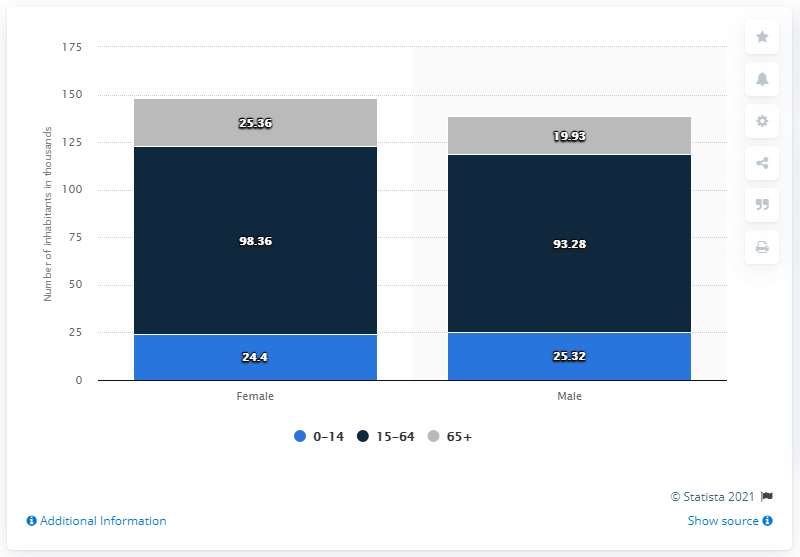Identify some key points in this picture. The age category that holds the highest value for both males and females is 15-64. There are approximately 19,930 individuals aged 65 and older in the given population. 